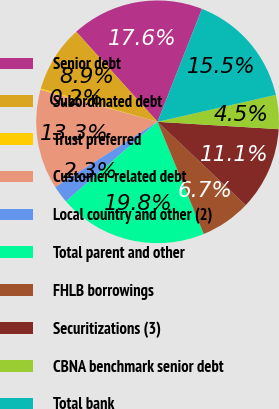Convert chart. <chart><loc_0><loc_0><loc_500><loc_500><pie_chart><fcel>Senior debt<fcel>Subordinated debt<fcel>Trust preferred<fcel>Customer-related debt<fcel>Local country and other (2)<fcel>Total parent and other<fcel>FHLB borrowings<fcel>Securitizations (3)<fcel>CBNA benchmark senior debt<fcel>Total bank<nl><fcel>17.65%<fcel>8.91%<fcel>0.16%<fcel>13.28%<fcel>2.35%<fcel>19.84%<fcel>6.72%<fcel>11.09%<fcel>4.53%<fcel>15.47%<nl></chart> 